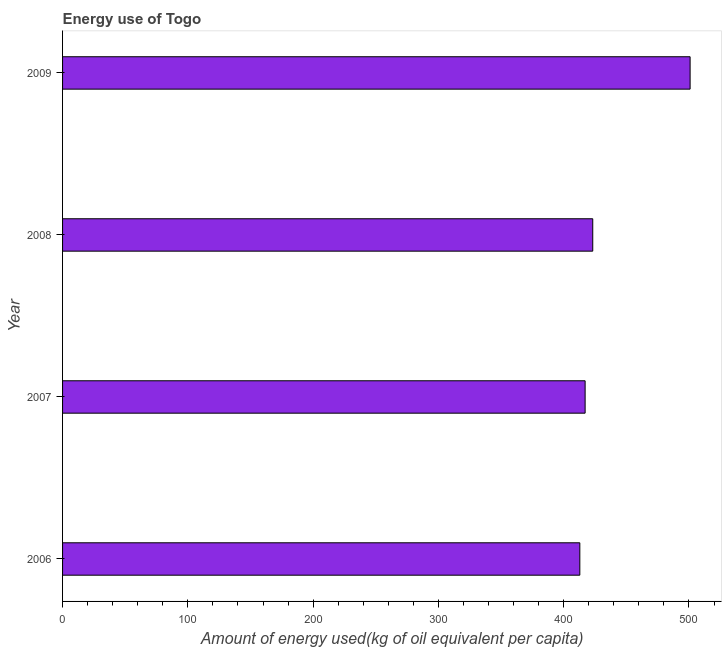Does the graph contain any zero values?
Offer a very short reply. No. Does the graph contain grids?
Offer a very short reply. No. What is the title of the graph?
Provide a succinct answer. Energy use of Togo. What is the label or title of the X-axis?
Provide a short and direct response. Amount of energy used(kg of oil equivalent per capita). What is the amount of energy used in 2008?
Provide a succinct answer. 423.2. Across all years, what is the maximum amount of energy used?
Offer a terse response. 500.93. Across all years, what is the minimum amount of energy used?
Give a very brief answer. 412.9. What is the sum of the amount of energy used?
Ensure brevity in your answer.  1754.14. What is the difference between the amount of energy used in 2007 and 2008?
Make the answer very short. -6.08. What is the average amount of energy used per year?
Make the answer very short. 438.54. What is the median amount of energy used?
Your answer should be compact. 420.16. Do a majority of the years between 2009 and 2006 (inclusive) have amount of energy used greater than 140 kg?
Provide a short and direct response. Yes. What is the ratio of the amount of energy used in 2006 to that in 2008?
Your response must be concise. 0.98. Is the difference between the amount of energy used in 2008 and 2009 greater than the difference between any two years?
Offer a very short reply. No. What is the difference between the highest and the second highest amount of energy used?
Ensure brevity in your answer.  77.72. Is the sum of the amount of energy used in 2006 and 2009 greater than the maximum amount of energy used across all years?
Make the answer very short. Yes. What is the difference between the highest and the lowest amount of energy used?
Keep it short and to the point. 88.03. How many bars are there?
Your answer should be very brief. 4. Are all the bars in the graph horizontal?
Your answer should be very brief. Yes. What is the difference between two consecutive major ticks on the X-axis?
Give a very brief answer. 100. What is the Amount of energy used(kg of oil equivalent per capita) of 2006?
Provide a succinct answer. 412.9. What is the Amount of energy used(kg of oil equivalent per capita) of 2007?
Make the answer very short. 417.12. What is the Amount of energy used(kg of oil equivalent per capita) of 2008?
Provide a succinct answer. 423.2. What is the Amount of energy used(kg of oil equivalent per capita) of 2009?
Your answer should be compact. 500.93. What is the difference between the Amount of energy used(kg of oil equivalent per capita) in 2006 and 2007?
Your answer should be compact. -4.22. What is the difference between the Amount of energy used(kg of oil equivalent per capita) in 2006 and 2008?
Ensure brevity in your answer.  -10.31. What is the difference between the Amount of energy used(kg of oil equivalent per capita) in 2006 and 2009?
Offer a very short reply. -88.03. What is the difference between the Amount of energy used(kg of oil equivalent per capita) in 2007 and 2008?
Make the answer very short. -6.08. What is the difference between the Amount of energy used(kg of oil equivalent per capita) in 2007 and 2009?
Provide a short and direct response. -83.81. What is the difference between the Amount of energy used(kg of oil equivalent per capita) in 2008 and 2009?
Offer a terse response. -77.72. What is the ratio of the Amount of energy used(kg of oil equivalent per capita) in 2006 to that in 2008?
Make the answer very short. 0.98. What is the ratio of the Amount of energy used(kg of oil equivalent per capita) in 2006 to that in 2009?
Provide a short and direct response. 0.82. What is the ratio of the Amount of energy used(kg of oil equivalent per capita) in 2007 to that in 2008?
Offer a very short reply. 0.99. What is the ratio of the Amount of energy used(kg of oil equivalent per capita) in 2007 to that in 2009?
Make the answer very short. 0.83. What is the ratio of the Amount of energy used(kg of oil equivalent per capita) in 2008 to that in 2009?
Ensure brevity in your answer.  0.84. 